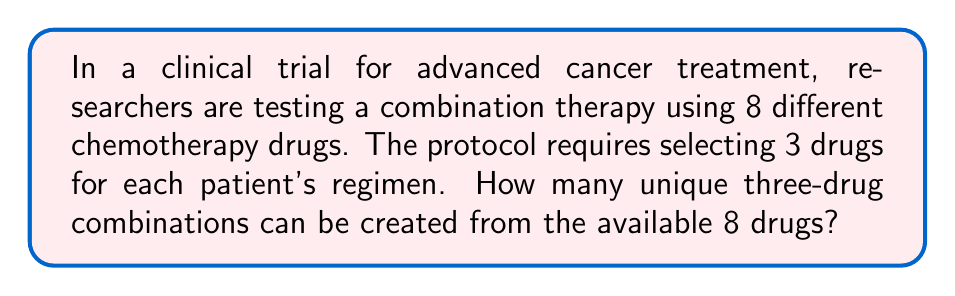What is the answer to this math problem? To solve this problem, we need to use the combination formula, as the order of selection doesn't matter (e.g., selecting drugs A, B, and C is the same as selecting B, C, and A).

The combination formula is:

$${n \choose r} = \frac{n!}{r!(n-r)!}$$

Where:
$n$ = total number of items to choose from (8 drugs)
$r$ = number of items being chosen (3 drugs)

Let's substitute these values:

$${8 \choose 3} = \frac{8!}{3!(8-3)!} = \frac{8!}{3!5!}$$

Now, let's calculate step by step:

1) Expand this:
   $$\frac{8 \cdot 7 \cdot 6 \cdot 5!}{(3 \cdot 2 \cdot 1) \cdot 5!}$$

2) The 5! cancels out in the numerator and denominator:
   $$\frac{8 \cdot 7 \cdot 6}{3 \cdot 2 \cdot 1}$$

3) Multiply the numerator and denominator:
   $$\frac{336}{6}$$

4) Divide:
   $$56$$

Therefore, there are 56 unique three-drug combinations possible from the 8 available drugs.
Answer: 56 